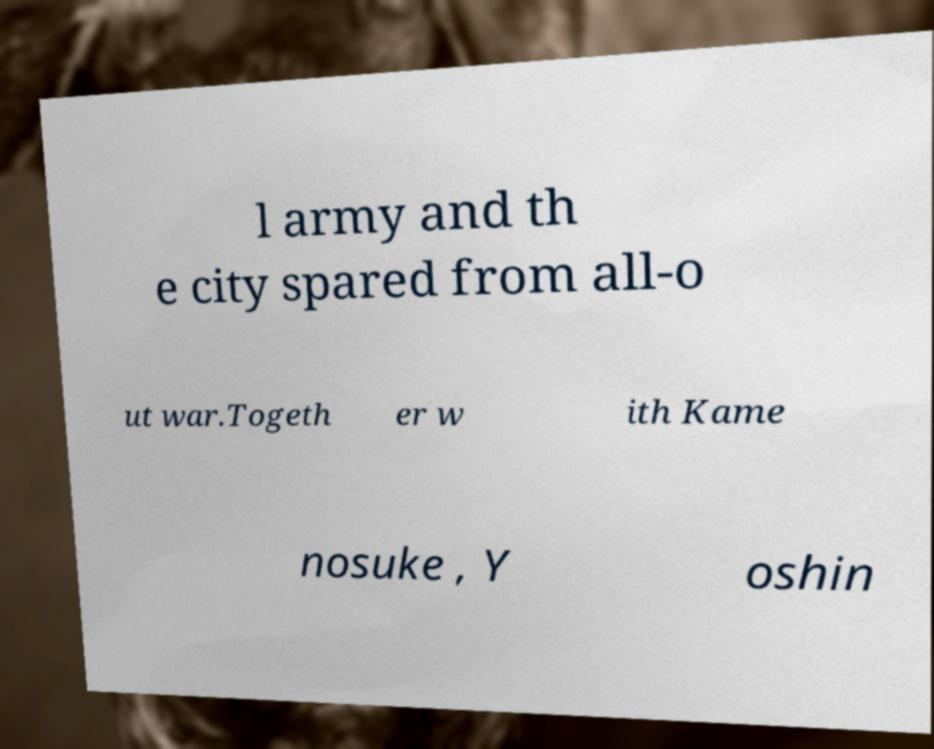What messages or text are displayed in this image? I need them in a readable, typed format. l army and th e city spared from all-o ut war.Togeth er w ith Kame nosuke , Y oshin 